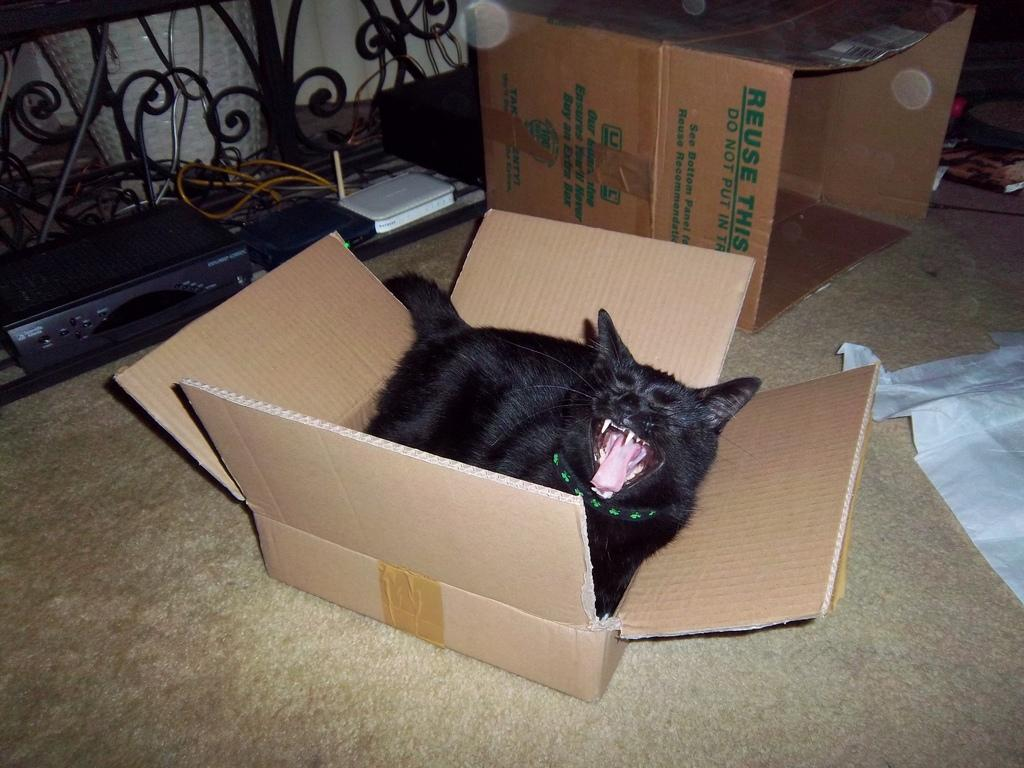Provide a one-sentence caption for the provided image. A black cat in a carboard box in front of another cardboard box that encourages you to reuse it. 